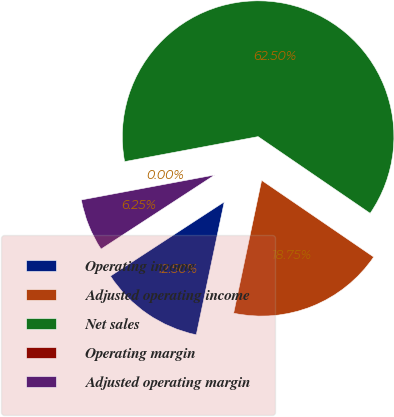Convert chart. <chart><loc_0><loc_0><loc_500><loc_500><pie_chart><fcel>Operating income<fcel>Adjusted operating income<fcel>Net sales<fcel>Operating margin<fcel>Adjusted operating margin<nl><fcel>12.5%<fcel>18.75%<fcel>62.5%<fcel>0.0%<fcel>6.25%<nl></chart> 